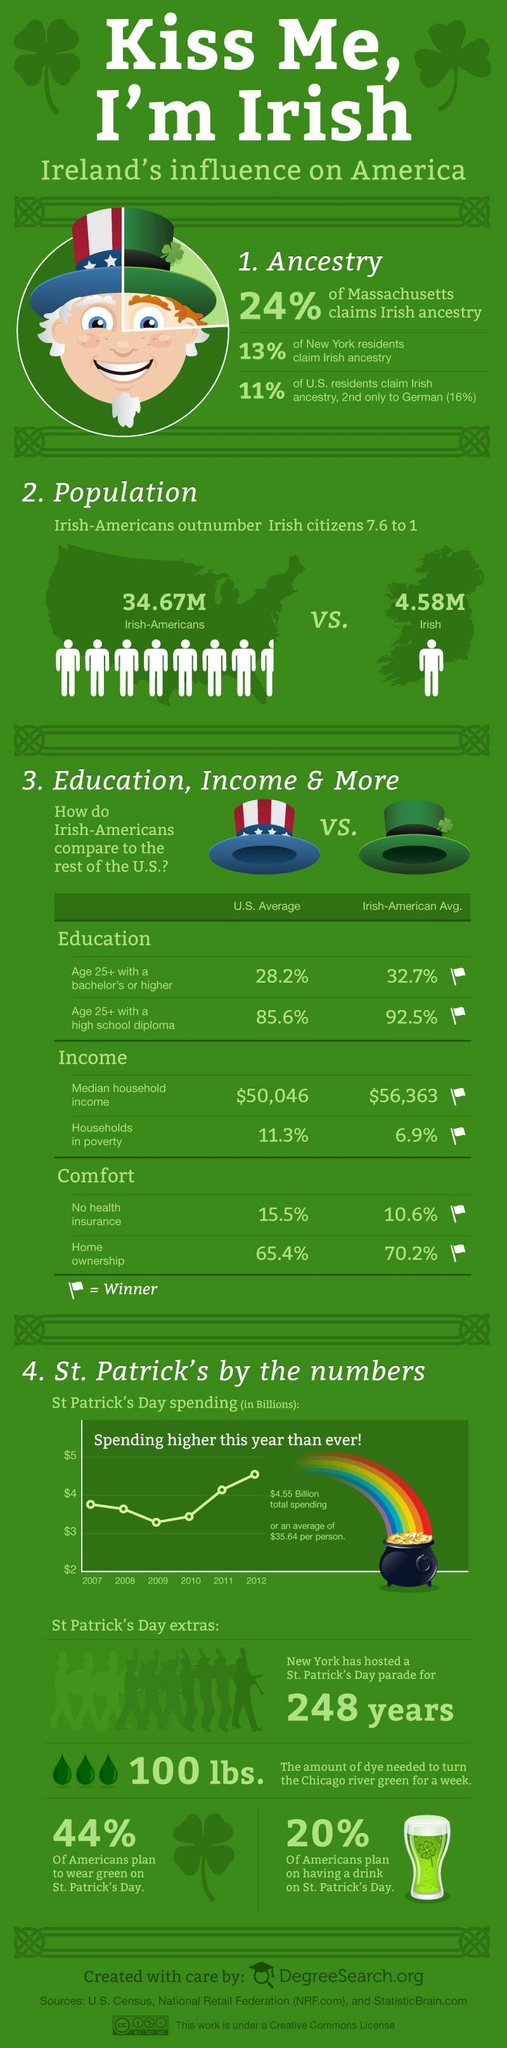What percentage of Americans have no plan to wear green on St.Patrick's day?
Answer the question with a short phrase. 56% What percentage of German residents didn't claim Irish ancestry? 84% What percentage of Americans have no plan on having a drink on St.Patrick's day? 80% What percentage of New York residents didn't claim Irish ancestry? 87% What percentage of U.S residents didn't claim Irish ancestry? 89% 